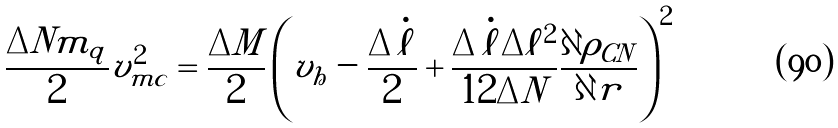Convert formula to latex. <formula><loc_0><loc_0><loc_500><loc_500>\frac { \Delta N m _ { q } } { 2 } v _ { m c } ^ { 2 } = \frac { \Delta M } { 2 } \left ( v _ { h } - \frac { \Delta \dot { \ell } } { 2 } + \frac { \Delta \dot { \ell } \Delta \ell ^ { 2 } } { 1 2 \Delta N } \frac { \partial \rho _ { C N } } { \partial r } \right ) ^ { 2 }</formula> 